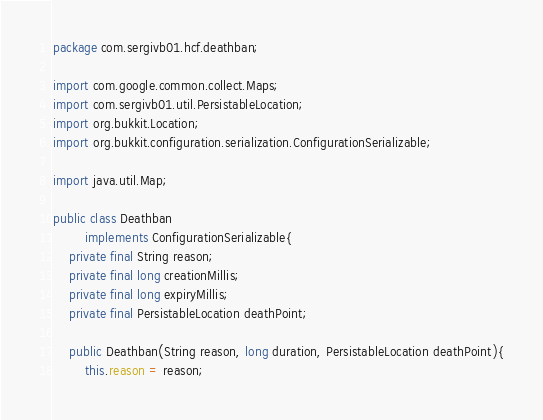Convert code to text. <code><loc_0><loc_0><loc_500><loc_500><_Java_>package com.sergivb01.hcf.deathban;

import com.google.common.collect.Maps;
import com.sergivb01.util.PersistableLocation;
import org.bukkit.Location;
import org.bukkit.configuration.serialization.ConfigurationSerializable;

import java.util.Map;

public class Deathban
		implements ConfigurationSerializable{
	private final String reason;
	private final long creationMillis;
	private final long expiryMillis;
	private final PersistableLocation deathPoint;

	public Deathban(String reason, long duration, PersistableLocation deathPoint){
		this.reason = reason;</code> 